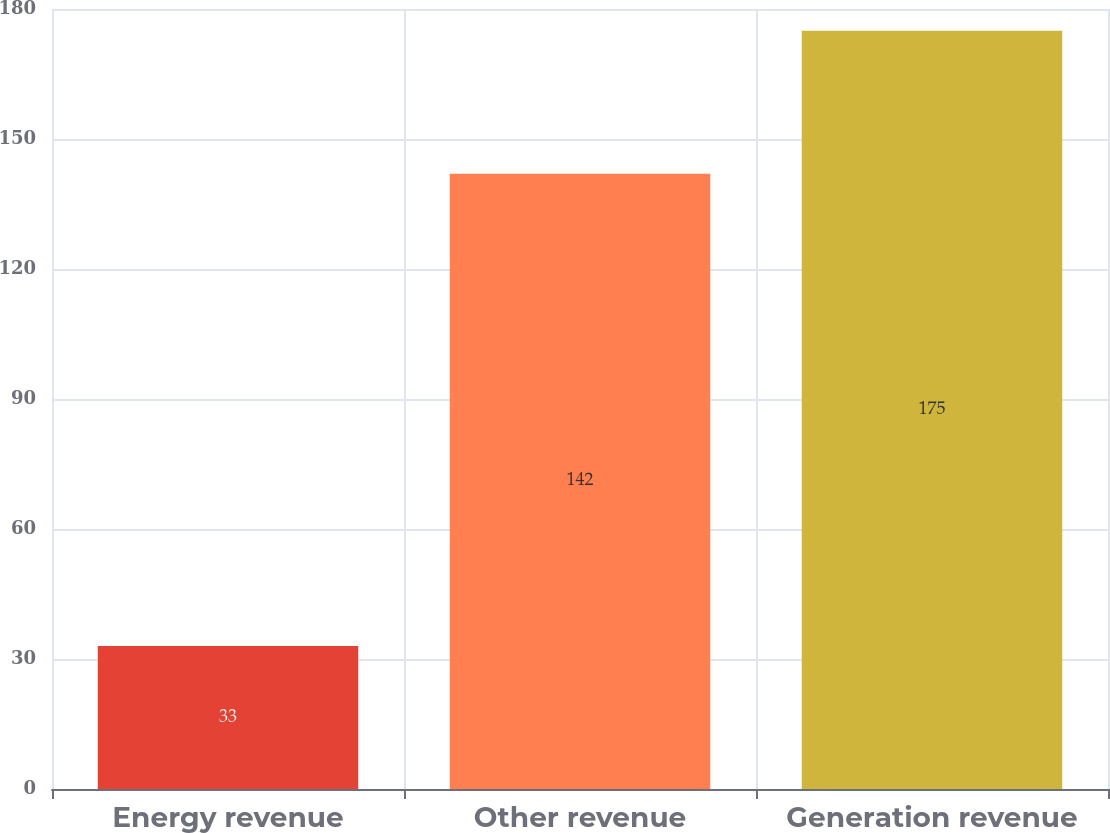Convert chart. <chart><loc_0><loc_0><loc_500><loc_500><bar_chart><fcel>Energy revenue<fcel>Other revenue<fcel>Generation revenue<nl><fcel>33<fcel>142<fcel>175<nl></chart> 